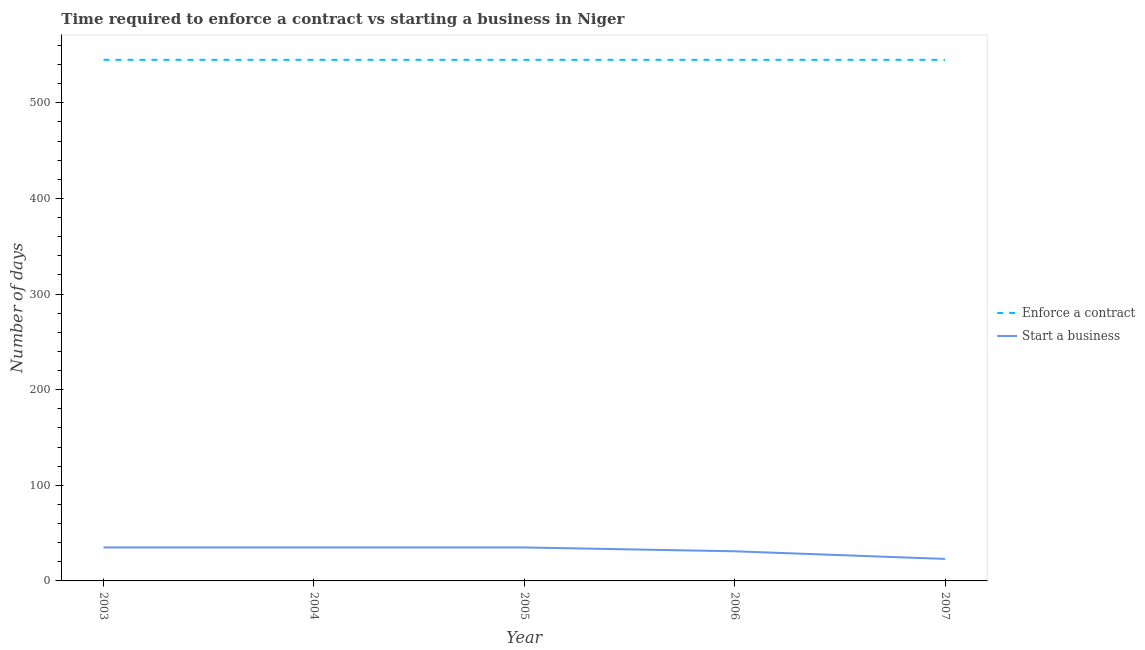Does the line corresponding to number of days to start a business intersect with the line corresponding to number of days to enforece a contract?
Keep it short and to the point. No. Is the number of lines equal to the number of legend labels?
Your answer should be very brief. Yes. What is the number of days to start a business in 2003?
Your answer should be compact. 35. Across all years, what is the maximum number of days to start a business?
Offer a terse response. 35. Across all years, what is the minimum number of days to start a business?
Offer a terse response. 23. In which year was the number of days to start a business maximum?
Provide a succinct answer. 2003. In which year was the number of days to start a business minimum?
Provide a succinct answer. 2007. What is the total number of days to enforece a contract in the graph?
Offer a terse response. 2725. What is the difference between the number of days to enforece a contract in 2003 and that in 2006?
Ensure brevity in your answer.  0. What is the difference between the number of days to start a business in 2005 and the number of days to enforece a contract in 2003?
Your answer should be compact. -510. What is the average number of days to start a business per year?
Offer a very short reply. 31.8. In the year 2004, what is the difference between the number of days to start a business and number of days to enforece a contract?
Keep it short and to the point. -510. In how many years, is the number of days to start a business greater than 340 days?
Your answer should be compact. 0. What is the ratio of the number of days to start a business in 2005 to that in 2006?
Make the answer very short. 1.13. Is the number of days to enforece a contract in 2004 less than that in 2007?
Provide a succinct answer. No. What is the difference between the highest and the lowest number of days to start a business?
Keep it short and to the point. 12. Is the sum of the number of days to enforece a contract in 2004 and 2007 greater than the maximum number of days to start a business across all years?
Your answer should be very brief. Yes. Does the number of days to start a business monotonically increase over the years?
Ensure brevity in your answer.  No. Is the number of days to enforece a contract strictly greater than the number of days to start a business over the years?
Offer a very short reply. Yes. How many years are there in the graph?
Keep it short and to the point. 5. What is the difference between two consecutive major ticks on the Y-axis?
Offer a terse response. 100. Does the graph contain any zero values?
Provide a succinct answer. No. Where does the legend appear in the graph?
Give a very brief answer. Center right. How are the legend labels stacked?
Give a very brief answer. Vertical. What is the title of the graph?
Keep it short and to the point. Time required to enforce a contract vs starting a business in Niger. Does "GDP" appear as one of the legend labels in the graph?
Your answer should be compact. No. What is the label or title of the X-axis?
Offer a very short reply. Year. What is the label or title of the Y-axis?
Provide a succinct answer. Number of days. What is the Number of days of Enforce a contract in 2003?
Provide a succinct answer. 545. What is the Number of days of Enforce a contract in 2004?
Ensure brevity in your answer.  545. What is the Number of days in Start a business in 2004?
Make the answer very short. 35. What is the Number of days in Enforce a contract in 2005?
Your answer should be very brief. 545. What is the Number of days in Enforce a contract in 2006?
Your answer should be very brief. 545. What is the Number of days of Enforce a contract in 2007?
Keep it short and to the point. 545. What is the Number of days of Start a business in 2007?
Provide a short and direct response. 23. Across all years, what is the maximum Number of days of Enforce a contract?
Offer a terse response. 545. Across all years, what is the maximum Number of days in Start a business?
Your answer should be compact. 35. Across all years, what is the minimum Number of days of Enforce a contract?
Offer a very short reply. 545. Across all years, what is the minimum Number of days of Start a business?
Keep it short and to the point. 23. What is the total Number of days of Enforce a contract in the graph?
Offer a very short reply. 2725. What is the total Number of days of Start a business in the graph?
Your response must be concise. 159. What is the difference between the Number of days in Enforce a contract in 2003 and that in 2004?
Your answer should be compact. 0. What is the difference between the Number of days in Start a business in 2003 and that in 2004?
Offer a very short reply. 0. What is the difference between the Number of days of Start a business in 2003 and that in 2005?
Provide a succinct answer. 0. What is the difference between the Number of days of Enforce a contract in 2004 and that in 2005?
Your answer should be compact. 0. What is the difference between the Number of days of Start a business in 2004 and that in 2006?
Provide a succinct answer. 4. What is the difference between the Number of days of Enforce a contract in 2005 and that in 2006?
Your answer should be very brief. 0. What is the difference between the Number of days in Start a business in 2005 and that in 2006?
Provide a succinct answer. 4. What is the difference between the Number of days in Enforce a contract in 2005 and that in 2007?
Keep it short and to the point. 0. What is the difference between the Number of days of Start a business in 2006 and that in 2007?
Give a very brief answer. 8. What is the difference between the Number of days in Enforce a contract in 2003 and the Number of days in Start a business in 2004?
Make the answer very short. 510. What is the difference between the Number of days of Enforce a contract in 2003 and the Number of days of Start a business in 2005?
Give a very brief answer. 510. What is the difference between the Number of days in Enforce a contract in 2003 and the Number of days in Start a business in 2006?
Your response must be concise. 514. What is the difference between the Number of days of Enforce a contract in 2003 and the Number of days of Start a business in 2007?
Your answer should be compact. 522. What is the difference between the Number of days of Enforce a contract in 2004 and the Number of days of Start a business in 2005?
Offer a very short reply. 510. What is the difference between the Number of days of Enforce a contract in 2004 and the Number of days of Start a business in 2006?
Provide a succinct answer. 514. What is the difference between the Number of days in Enforce a contract in 2004 and the Number of days in Start a business in 2007?
Give a very brief answer. 522. What is the difference between the Number of days in Enforce a contract in 2005 and the Number of days in Start a business in 2006?
Give a very brief answer. 514. What is the difference between the Number of days of Enforce a contract in 2005 and the Number of days of Start a business in 2007?
Provide a succinct answer. 522. What is the difference between the Number of days of Enforce a contract in 2006 and the Number of days of Start a business in 2007?
Offer a terse response. 522. What is the average Number of days of Enforce a contract per year?
Provide a succinct answer. 545. What is the average Number of days in Start a business per year?
Make the answer very short. 31.8. In the year 2003, what is the difference between the Number of days of Enforce a contract and Number of days of Start a business?
Make the answer very short. 510. In the year 2004, what is the difference between the Number of days in Enforce a contract and Number of days in Start a business?
Your answer should be very brief. 510. In the year 2005, what is the difference between the Number of days in Enforce a contract and Number of days in Start a business?
Offer a terse response. 510. In the year 2006, what is the difference between the Number of days in Enforce a contract and Number of days in Start a business?
Your answer should be compact. 514. In the year 2007, what is the difference between the Number of days of Enforce a contract and Number of days of Start a business?
Your answer should be very brief. 522. What is the ratio of the Number of days in Enforce a contract in 2003 to that in 2004?
Make the answer very short. 1. What is the ratio of the Number of days in Enforce a contract in 2003 to that in 2005?
Make the answer very short. 1. What is the ratio of the Number of days of Enforce a contract in 2003 to that in 2006?
Provide a short and direct response. 1. What is the ratio of the Number of days of Start a business in 2003 to that in 2006?
Keep it short and to the point. 1.13. What is the ratio of the Number of days in Enforce a contract in 2003 to that in 2007?
Provide a short and direct response. 1. What is the ratio of the Number of days in Start a business in 2003 to that in 2007?
Offer a terse response. 1.52. What is the ratio of the Number of days of Enforce a contract in 2004 to that in 2005?
Keep it short and to the point. 1. What is the ratio of the Number of days of Start a business in 2004 to that in 2005?
Your answer should be very brief. 1. What is the ratio of the Number of days in Enforce a contract in 2004 to that in 2006?
Provide a succinct answer. 1. What is the ratio of the Number of days in Start a business in 2004 to that in 2006?
Your response must be concise. 1.13. What is the ratio of the Number of days of Start a business in 2004 to that in 2007?
Provide a short and direct response. 1.52. What is the ratio of the Number of days of Enforce a contract in 2005 to that in 2006?
Make the answer very short. 1. What is the ratio of the Number of days of Start a business in 2005 to that in 2006?
Ensure brevity in your answer.  1.13. What is the ratio of the Number of days in Enforce a contract in 2005 to that in 2007?
Provide a succinct answer. 1. What is the ratio of the Number of days in Start a business in 2005 to that in 2007?
Provide a succinct answer. 1.52. What is the ratio of the Number of days in Start a business in 2006 to that in 2007?
Keep it short and to the point. 1.35. What is the difference between the highest and the lowest Number of days in Start a business?
Your answer should be very brief. 12. 